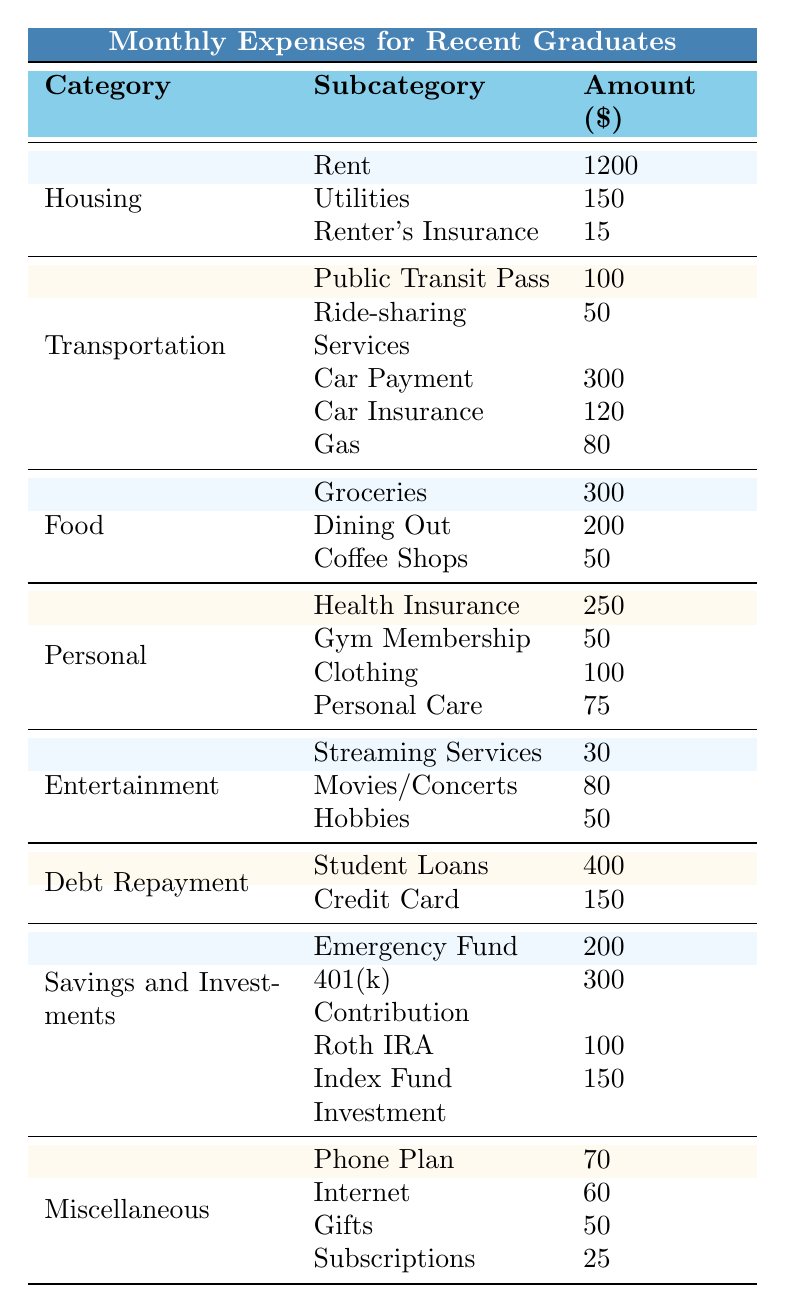What is the total monthly expense for Housing? To find the total monthly expense for Housing, add the amounts for Rent (1200), Utilities (150), and Renter's Insurance (15). Calculation: 1200 + 150 + 15 = 1365.
Answer: 1365 How much does a recent graduate spend on Food each month? The amounts for Food are Groceries (300), Dining Out (200), and Coffee Shops (50). To find the total, sum these values: 300 + 200 + 50 = 550.
Answer: 550 Is the amount spent on Transportation greater than the amount spent on Entertainment? The total for Transportation is 650 (100 + 50 + 300 + 120 + 80) and for Entertainment is 160 (30 + 80 + 50). Since 650 > 160, the statement is true.
Answer: Yes What are the total savings and investments per month? For Savings and Investments, the amounts are Emergency Fund (200), 401(k) Contribution (300), Roth IRA (100), and Index Fund Investment (150). Adding these gives 200 + 300 + 100 + 150 = 750.
Answer: 750 Which category has the highest expense? The largest expense is found by comparing total expenses in all categories: Housing (1365), Transportation (650), Food (550), Personal (475), Entertainment (160), Debt Repayment (550), Savings and Investments (750), Miscellaneous (205). Housing has the highest spending at 1365.
Answer: Housing What is the combined cost of debt repayment? The total for Debt Repayment includes Student Loans (400) and Credit Card (150). Adding these amounts gives 400 + 150 = 550.
Answer: 550 How much more is spent on Transportation compared to Personal expenses? Transportation total is 650, and Personal expenses total 475. To find the difference, subtract Personal from Transportation: 650 - 475 = 175.
Answer: 175 If a recent graduate wants to cut their monthly food expenses by 20%, how much would they save? Current food expense is 550. To find 20% of this, multiply 550 by 0.20: 550 * 0.20 = 110.
Answer: 110 What is the average expense for the entertainment category? The entertainment expenses are Streaming Services (30), Movies/Concerts (80), and Hobbies (50). The average is calculated by summing these amounts (30 + 80 + 50 = 160) and dividing by the number of items (3): 160 / 3 ≈ 53.33.
Answer: 53.33 Which category has the least monthly expense? The category with the least expenses can be determined by comparing totals: Housing (1365), Transportation (650), Food (550), Personal (475), Entertainment (160), Debt Repayment (550), Savings and Investments (750), Miscellaneous (205). Entertainment has the lowest total at 160.
Answer: Entertainment 